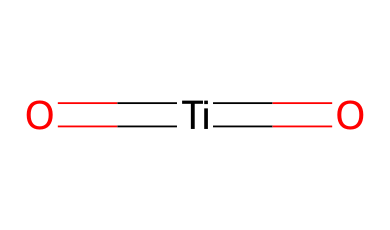What is the central atom in titanium dioxide? The central atom of the chemical structure is titanium, which can be identified by its position in the middle of the structure connected to two oxygen atoms through double bonds.
Answer: titanium How many oxygen atoms are present in titanium dioxide? The structure shows two oxygen atoms connected to the titanium atom through double bonds, which means there are two oxygen atoms.
Answer: two What type of chemical bonding is present in titanium dioxide? The chemical consists of double bonds between titanium and each of the oxygen atoms, which is a characteristic of covalent bonding.
Answer: covalent What is the general property of titanium dioxide in sunscreens? Titanium dioxide is known for its ability to block ultraviolet (UV) radiation, which protects the skin from sun damage.
Answer: UV protection Why is titanium dioxide considered a physical sunscreen agent? Titanium dioxide reflects and scatters UV radiation rather than absorbing it like chemical sunscreens do, which is indicative of its physical sunscreen properties.
Answer: reflects and scatters What are the possible states of titanium dioxide at room temperature? Titanium dioxide can exist in several crystalline forms, including rutile and anatase, at room temperature and is generally solid.
Answer: solid 